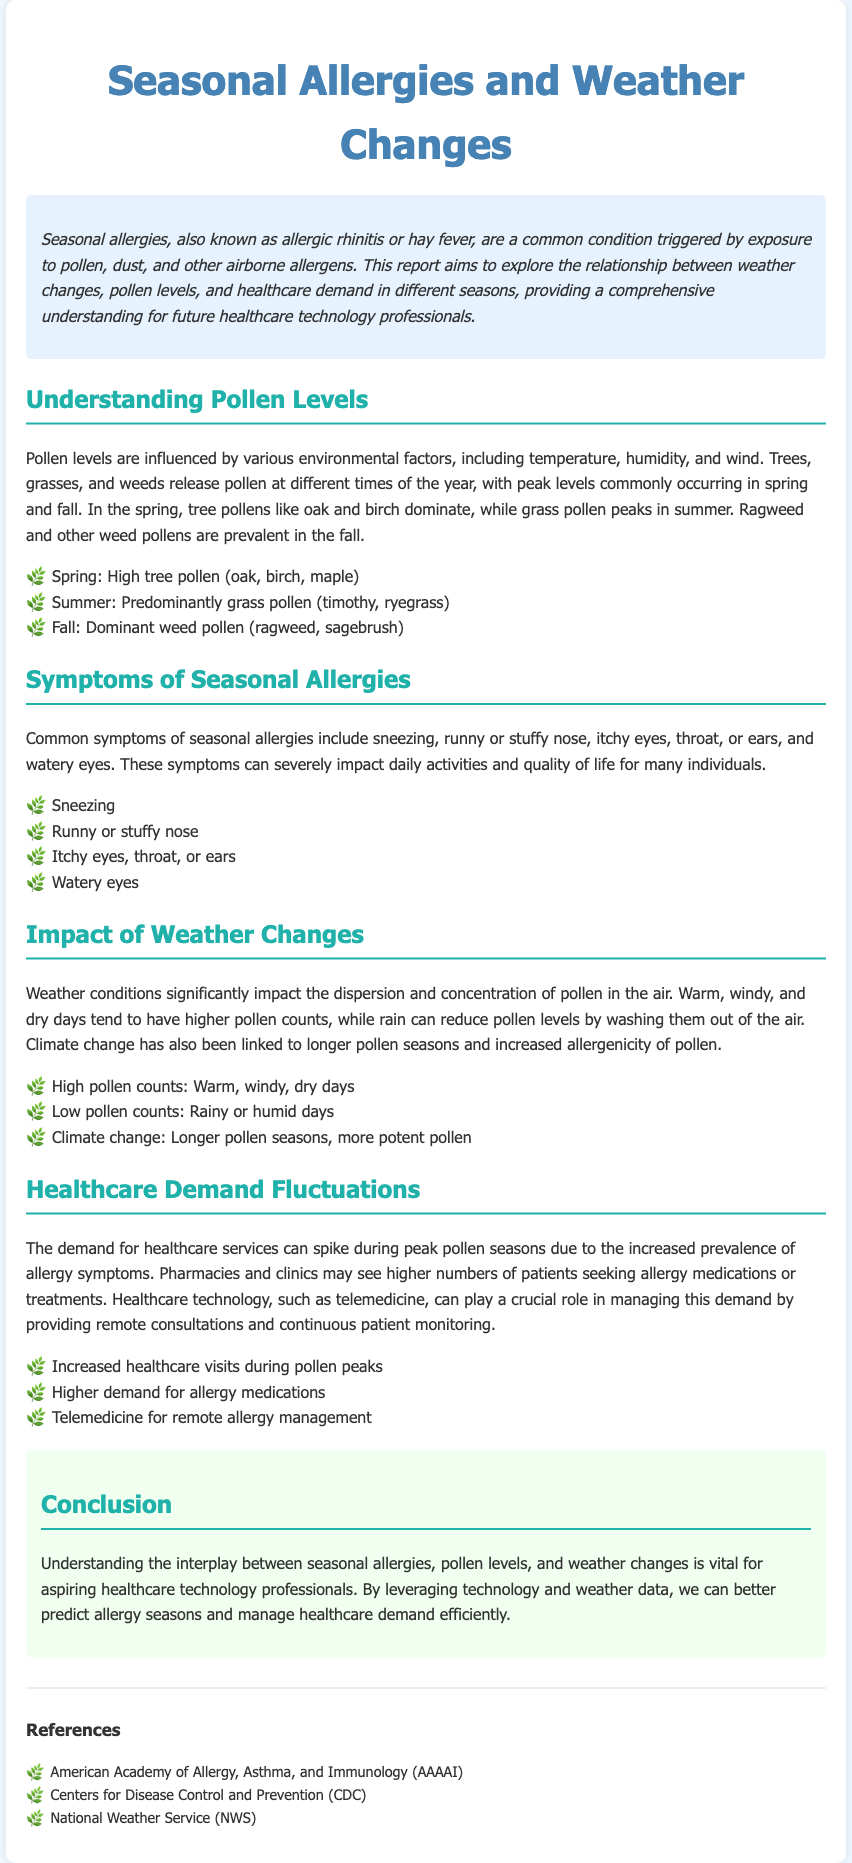What is another name for seasonal allergies? Seasonal allergies are also known as allergic rhinitis or hay fever.
Answer: allergic rhinitis During which season do tree pollens peak? Tree pollens peak commonly in spring.
Answer: spring What symptoms are associated with seasonal allergies? Common symptoms include sneezing, runny or stuffy nose, itchy eyes, throat, or ears, and watery eyes.
Answer: sneezing, runny or stuffy nose, itchy eyes, throat, or ears, watery eyes What weather conditions lead to higher pollen counts? Warm, windy, and dry days tend to have higher pollen counts.
Answer: warm, windy, dry days How does climate change affect pollen seasons? Climate change is linked to longer pollen seasons and increased allergenicity of pollen.
Answer: longer pollen seasons, more potent pollen What role can healthcare technology play during peak pollen seasons? Healthcare technology, such as telemedicine, can provide remote consultations and continuous patient monitoring.
Answer: telemedicine What might increase during pollen peaks? The demand for healthcare services can spike during peak pollen seasons.
Answer: healthcare visits What types of pollen dominate in the fall? Ragweed and other weed pollens are prevalent in the fall.
Answer: ragweed, other weed pollens 